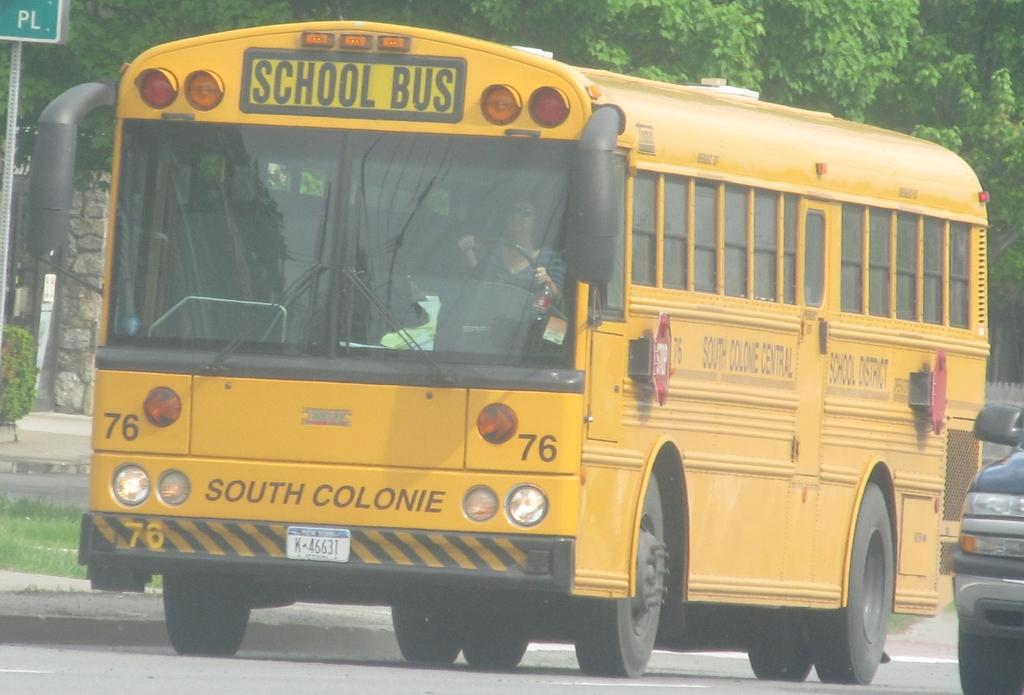<image>
Share a concise interpretation of the image provided. School Bus # 76, South Colonie Central, for kids going to and from school. 